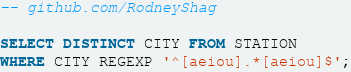<code> <loc_0><loc_0><loc_500><loc_500><_SQL_>-- github.com/RodneyShag

SELECT DISTINCT CITY FROM STATION
WHERE CITY REGEXP '^[aeiou].*[aeiou]$';
</code> 